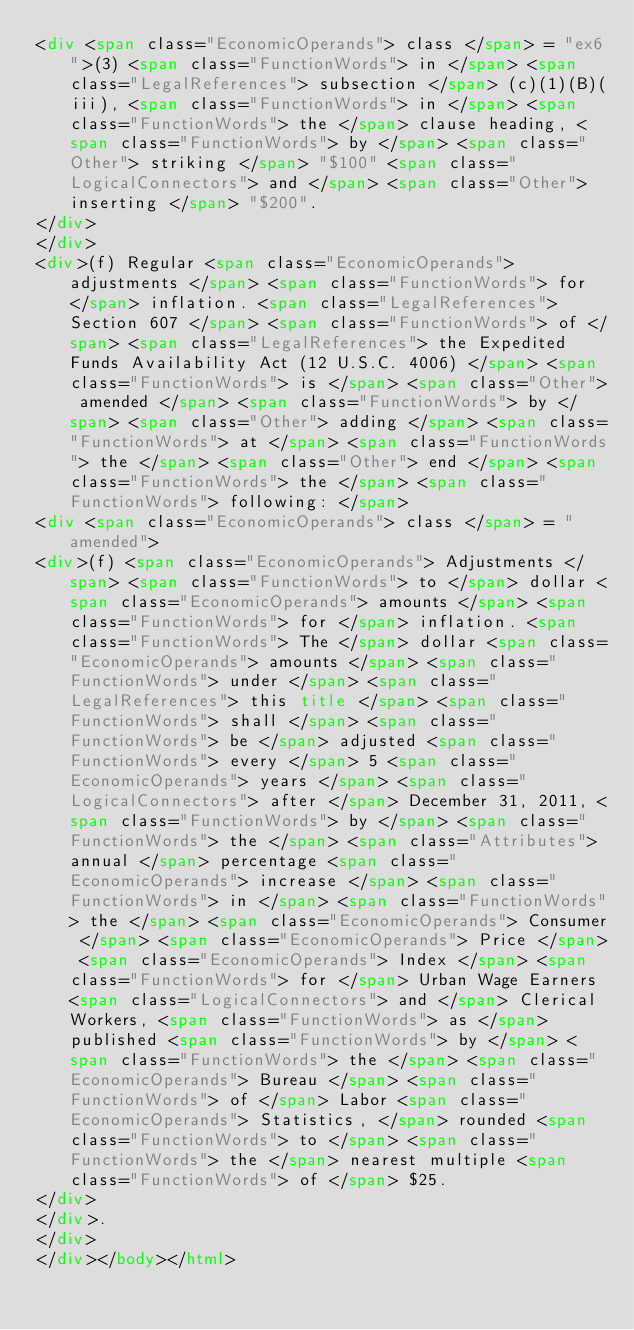Convert code to text. <code><loc_0><loc_0><loc_500><loc_500><_HTML_><div <span class="EconomicOperands"> class </span> = "ex6">(3) <span class="FunctionWords"> in </span> <span class="LegalReferences"> subsection </span> (c)(1)(B)(iii), <span class="FunctionWords"> in </span> <span class="FunctionWords"> the </span> clause heading, <span class="FunctionWords"> by </span> <span class="Other"> striking </span> "$100" <span class="LogicalConnectors"> and </span> <span class="Other"> inserting </span> "$200". 
</div>
</div>
<div>(f) Regular <span class="EconomicOperands"> adjustments </span> <span class="FunctionWords"> for </span> inflation. <span class="LegalReferences"> Section 607 </span> <span class="FunctionWords"> of </span> <span class="LegalReferences"> the Expedited Funds Availability Act (12 U.S.C. 4006) </span> <span class="FunctionWords"> is </span> <span class="Other"> amended </span> <span class="FunctionWords"> by </span> <span class="Other"> adding </span> <span class="FunctionWords"> at </span> <span class="FunctionWords"> the </span> <span class="Other"> end </span> <span class="FunctionWords"> the </span> <span class="FunctionWords"> following: </span> 
<div <span class="EconomicOperands"> class </span> = "amended">
<div>(f) <span class="EconomicOperands"> Adjustments </span> <span class="FunctionWords"> to </span> dollar <span class="EconomicOperands"> amounts </span> <span class="FunctionWords"> for </span> inflation. <span class="FunctionWords"> The </span> dollar <span class="EconomicOperands"> amounts </span> <span class="FunctionWords"> under </span> <span class="LegalReferences"> this title </span> <span class="FunctionWords"> shall </span> <span class="FunctionWords"> be </span> adjusted <span class="FunctionWords"> every </span> 5 <span class="EconomicOperands"> years </span> <span class="LogicalConnectors"> after </span> December 31, 2011, <span class="FunctionWords"> by </span> <span class="FunctionWords"> the </span> <span class="Attributes"> annual </span> percentage <span class="EconomicOperands"> increase </span> <span class="FunctionWords"> in </span> <span class="FunctionWords"> the </span> <span class="EconomicOperands"> Consumer </span> <span class="EconomicOperands"> Price </span> <span class="EconomicOperands"> Index </span> <span class="FunctionWords"> for </span> Urban Wage Earners <span class="LogicalConnectors"> and </span> Clerical Workers, <span class="FunctionWords"> as </span> published <span class="FunctionWords"> by </span> <span class="FunctionWords"> the </span> <span class="EconomicOperands"> Bureau </span> <span class="FunctionWords"> of </span> Labor <span class="EconomicOperands"> Statistics, </span> rounded <span class="FunctionWords"> to </span> <span class="FunctionWords"> the </span> nearest multiple <span class="FunctionWords"> of </span> $25. 
</div>
</div>. 
</div>
</div></body></html>
</code> 